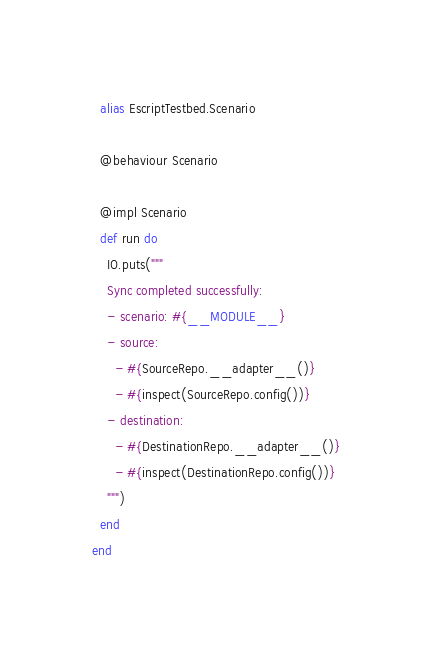Convert code to text. <code><loc_0><loc_0><loc_500><loc_500><_Elixir_>  alias EscriptTestbed.Scenario

  @behaviour Scenario

  @impl Scenario
  def run do
    IO.puts("""
    Sync completed successfully:
    - scenario: #{__MODULE__}
    - source:
      - #{SourceRepo.__adapter__()}
      - #{inspect(SourceRepo.config())}
    - destination:
      - #{DestinationRepo.__adapter__()}
      - #{inspect(DestinationRepo.config())}
    """)
  end
end
</code> 